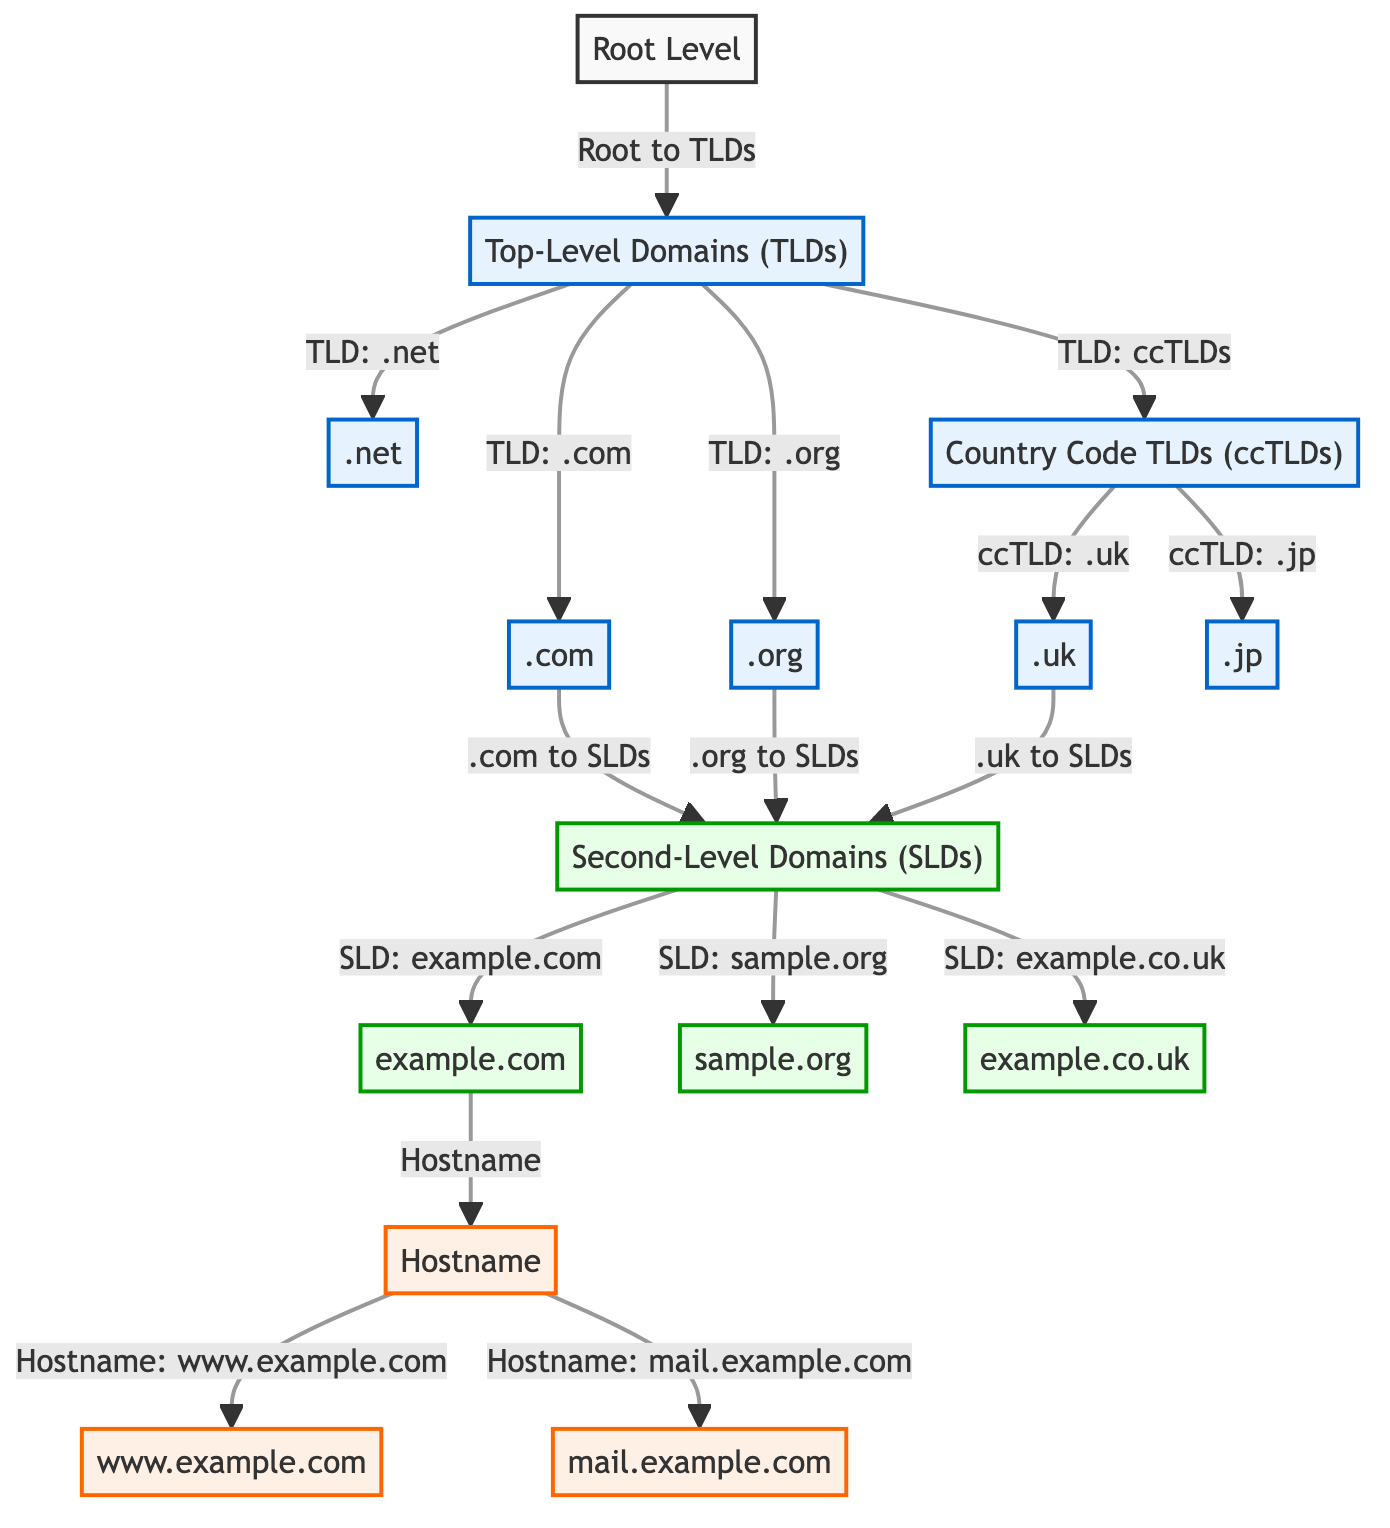What is the highest level in the DNS hierarchy? The diagram starts with the root level as the highest point in the hierarchy, indicating the top of the DNS structure.
Answer: Root Level How many Top-Level Domains (TLDs) are shown in the diagram? The TLDs listed in the diagram include .com, .org, .net, and country code TLDs, which branches into .uk and .jp. Counting these gives a total of five distinct TLDs.
Answer: 5 What type of domain is "example.com"? The domain "example.com" is identified under the second-level domains (SLDs) as per its placement in the diagram.
Answer: Second-Level Domain (SLD) Which Top-Level Domain (TLD) does ".uk" belong to? The diagram indicates that ".uk" is categorized under the Country Code Top-Level Domains (ccTLDs), which is a subgroup of the TLDs.
Answer: Country Code TLDs (ccTLDs) How many Second-Level Domains (SLDs) are listed in the diagram? The diagram displays three examples of SLDs: example.com, sample.org, and example.co.uk. Counting them results in a total of three SLDs.
Answer: 3 Which hostname is associated with "example.com" in the diagram? The diagram shows that "www.example.com" and "mail.example.com" are hostnames that are derived from the second-level domain "example.com."
Answer: www.example.com, mail.example.com How does the ".com" TLD relate to Second-Level Domains (SLDs)? The diagram illustrates that the ".com" TLD branches out directly to the second-level domains (SLDs), indicating a direct connection to SLDs under it.
Answer: Branches to SLDs What is a characteristic feature of the Root Level in this diagram? The root level serves as a foundational element from which various TLDs emerge, indicating its role as the starting point in the DNS hierarchy.
Answer: Starting point of DNS hierarchy 